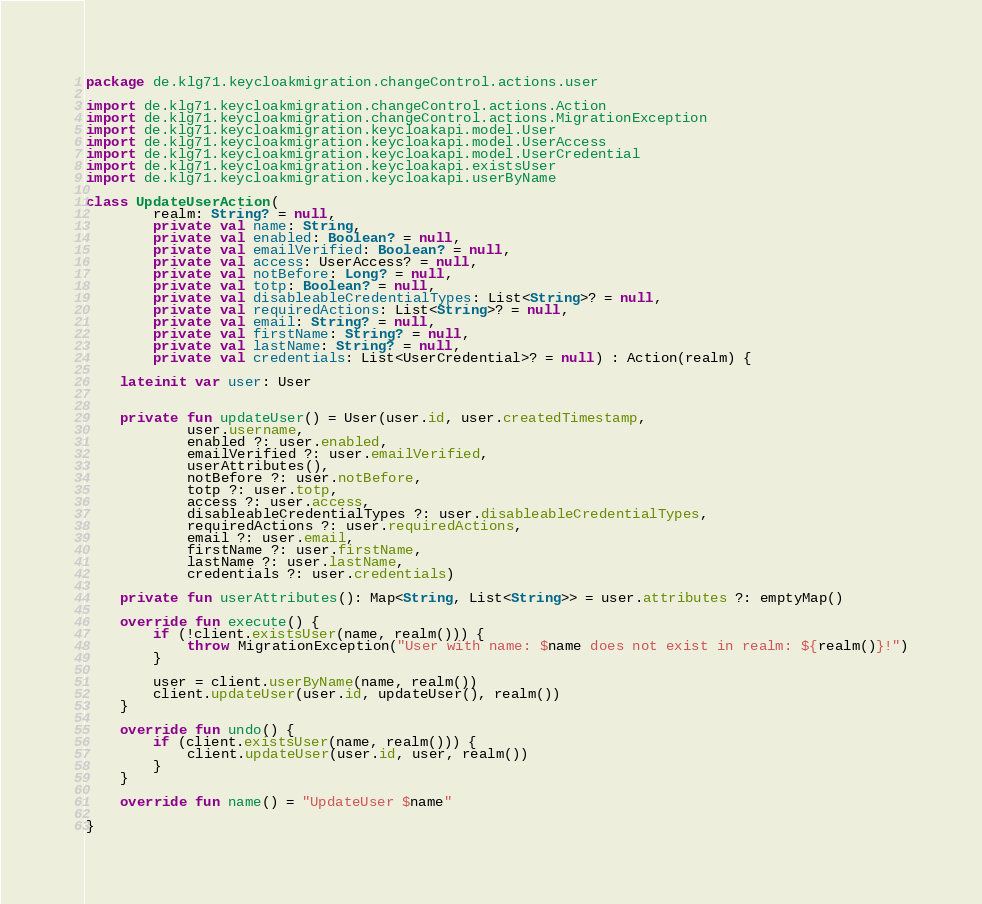<code> <loc_0><loc_0><loc_500><loc_500><_Kotlin_>package de.klg71.keycloakmigration.changeControl.actions.user

import de.klg71.keycloakmigration.changeControl.actions.Action
import de.klg71.keycloakmigration.changeControl.actions.MigrationException
import de.klg71.keycloakmigration.keycloakapi.model.User
import de.klg71.keycloakmigration.keycloakapi.model.UserAccess
import de.klg71.keycloakmigration.keycloakapi.model.UserCredential
import de.klg71.keycloakmigration.keycloakapi.existsUser
import de.klg71.keycloakmigration.keycloakapi.userByName

class UpdateUserAction(
        realm: String? = null,
        private val name: String,
        private val enabled: Boolean? = null,
        private val emailVerified: Boolean? = null,
        private val access: UserAccess? = null,
        private val notBefore: Long? = null,
        private val totp: Boolean? = null,
        private val disableableCredentialTypes: List<String>? = null,
        private val requiredActions: List<String>? = null,
        private val email: String? = null,
        private val firstName: String? = null,
        private val lastName: String? = null,
        private val credentials: List<UserCredential>? = null) : Action(realm) {

    lateinit var user: User


    private fun updateUser() = User(user.id, user.createdTimestamp,
            user.username,
            enabled ?: user.enabled,
            emailVerified ?: user.emailVerified,
            userAttributes(),
            notBefore ?: user.notBefore,
            totp ?: user.totp,
            access ?: user.access,
            disableableCredentialTypes ?: user.disableableCredentialTypes,
            requiredActions ?: user.requiredActions,
            email ?: user.email,
            firstName ?: user.firstName,
            lastName ?: user.lastName,
            credentials ?: user.credentials)

    private fun userAttributes(): Map<String, List<String>> = user.attributes ?: emptyMap()

    override fun execute() {
        if (!client.existsUser(name, realm())) {
            throw MigrationException("User with name: $name does not exist in realm: ${realm()}!")
        }

        user = client.userByName(name, realm())
        client.updateUser(user.id, updateUser(), realm())
    }

    override fun undo() {
        if (client.existsUser(name, realm())) {
            client.updateUser(user.id, user, realm())
        }
    }

    override fun name() = "UpdateUser $name"

}
</code> 